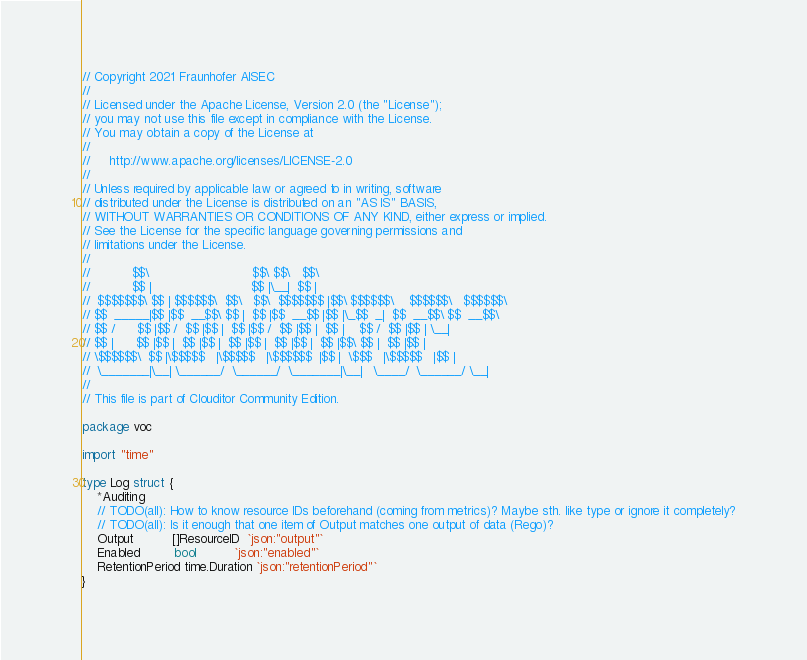<code> <loc_0><loc_0><loc_500><loc_500><_Go_>// Copyright 2021 Fraunhofer AISEC
//
// Licensed under the Apache License, Version 2.0 (the "License");
// you may not use this file except in compliance with the License.
// You may obtain a copy of the License at
//
//     http://www.apache.org/licenses/LICENSE-2.0
//
// Unless required by applicable law or agreed to in writing, software
// distributed under the License is distributed on an "AS IS" BASIS,
// WITHOUT WARRANTIES OR CONDITIONS OF ANY KIND, either express or implied.
// See the License for the specific language governing permissions and
// limitations under the License.
//
//           $$\                           $$\ $$\   $$\
//           $$ |                          $$ |\__|  $$ |
//  $$$$$$$\ $$ | $$$$$$\  $$\   $$\  $$$$$$$ |$$\ $$$$$$\    $$$$$$\   $$$$$$\
// $$  _____|$$ |$$  __$$\ $$ |  $$ |$$  __$$ |$$ |\_$$  _|  $$  __$$\ $$  __$$\
// $$ /      $$ |$$ /  $$ |$$ |  $$ |$$ /  $$ |$$ |  $$ |    $$ /  $$ |$$ | \__|
// $$ |      $$ |$$ |  $$ |$$ |  $$ |$$ |  $$ |$$ |  $$ |$$\ $$ |  $$ |$$ |
// \$$$$$$\  $$ |\$$$$$   |\$$$$$   |\$$$$$$  |$$ |  \$$$   |\$$$$$   |$$ |
//  \_______|\__| \______/  \______/  \_______|\__|   \____/  \______/ \__|
//
// This file is part of Clouditor Community Edition.

package voc

import "time"

type Log struct {
	*Auditing
	// TODO(all): How to know resource IDs beforehand (coming from metrics)? Maybe sth. like type or ignore it completely?
	// TODO(all): Is it enough that one item of Output matches one output of data (Rego)?
	Output          []ResourceID  `json:"output"`
	Enabled         bool          `json:"enabled"`
	RetentionPeriod time.Duration `json:"retentionPeriod"`
}
</code> 